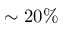<formula> <loc_0><loc_0><loc_500><loc_500>\sim 2 0 \%</formula> 